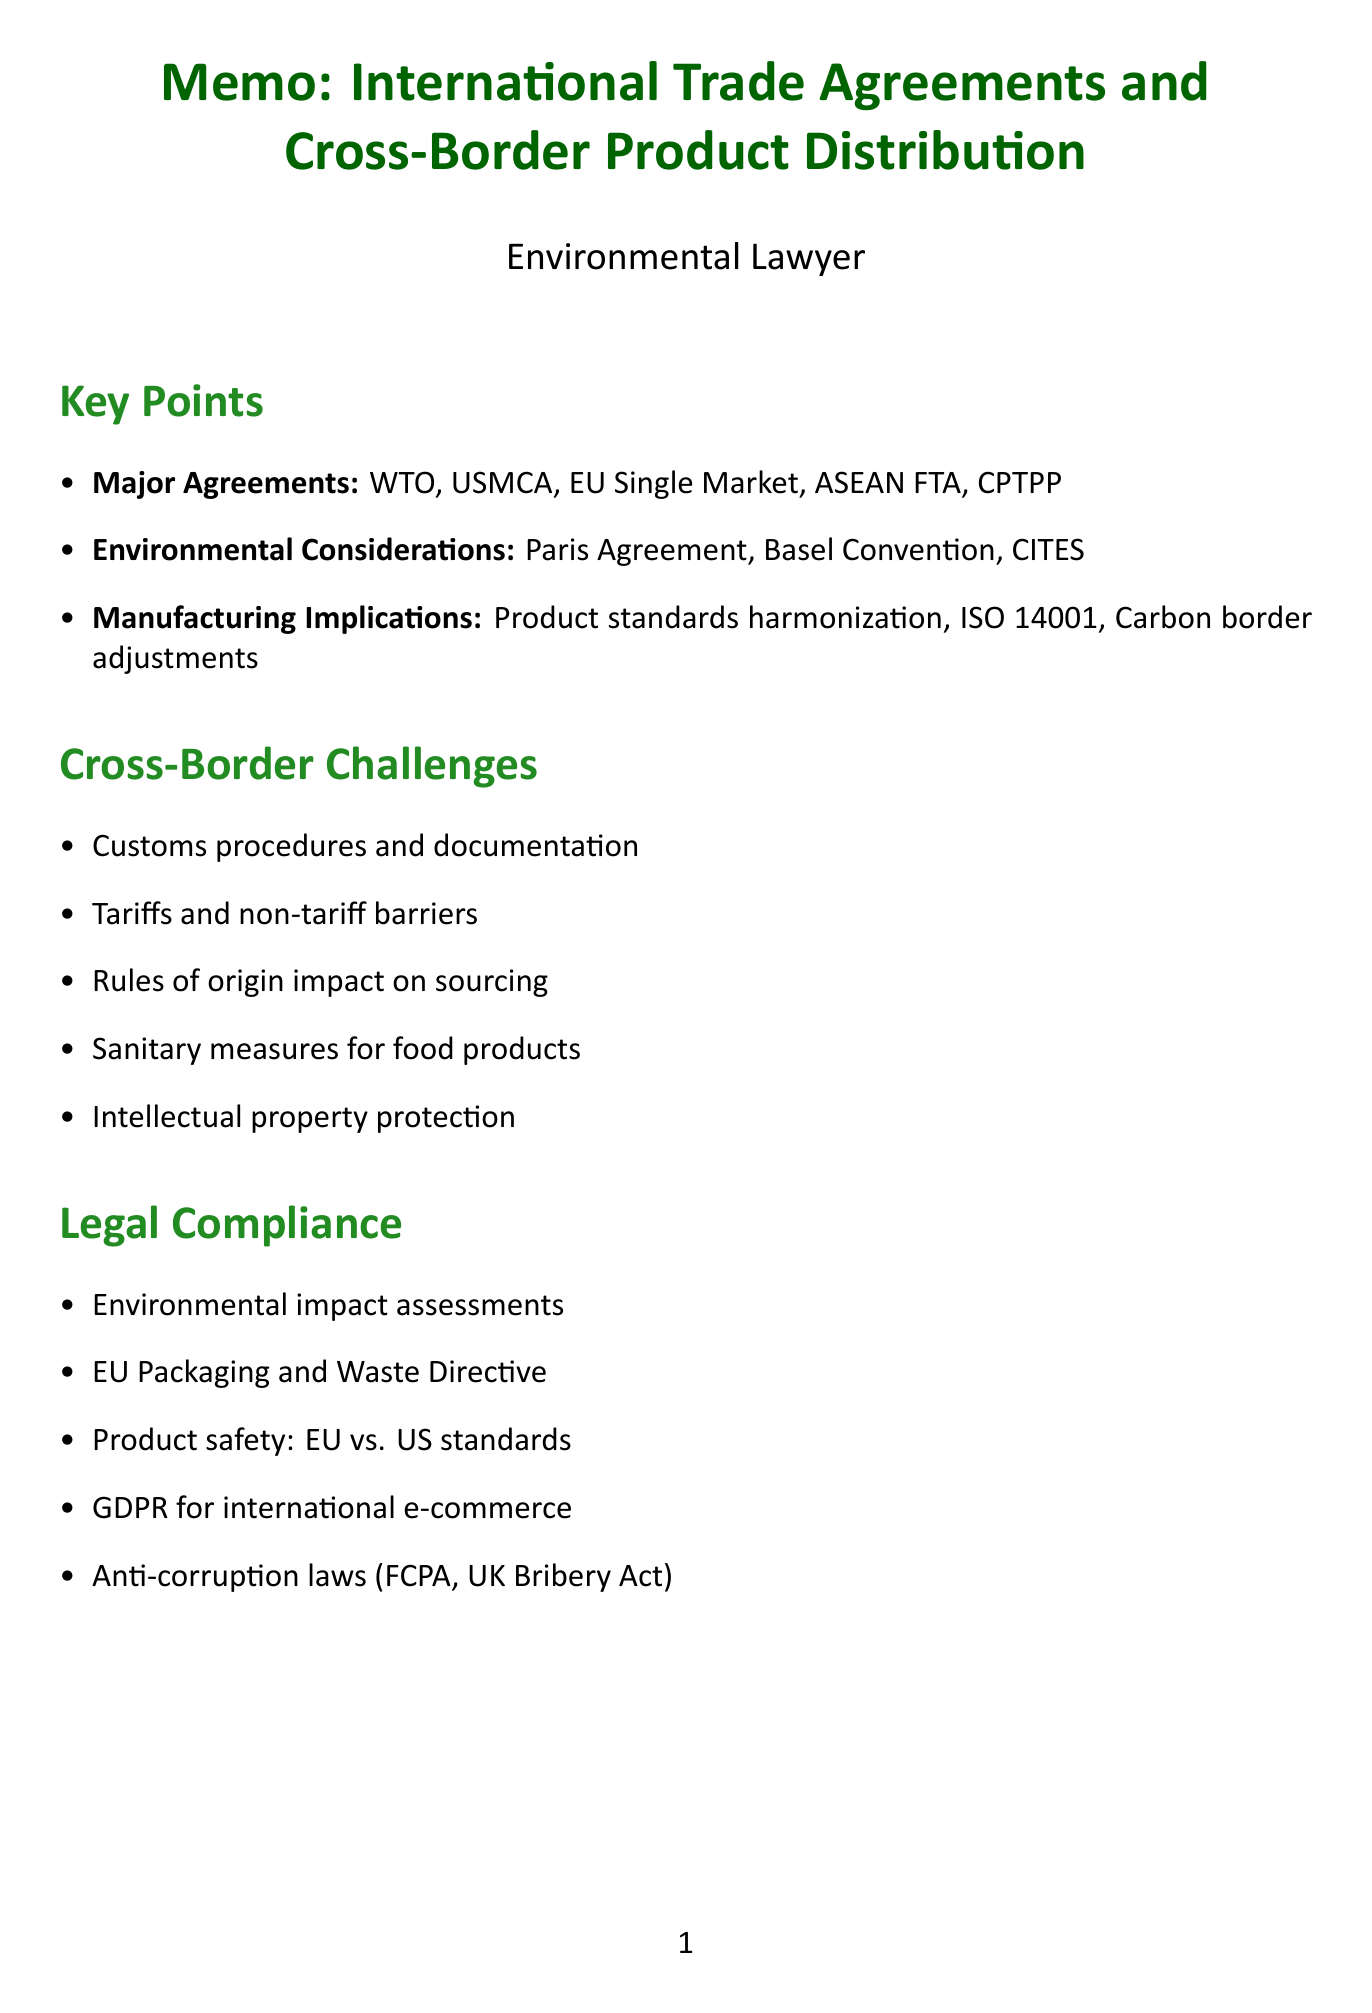What are the major trade agreements discussed? The document lists key international trade agreements including WTO, NAFTA/USMCA, EU Single Market, ASEAN FTA, and CPTPP.
Answer: WTO, NAFTA/USMCA, EU Single Market, ASEAN FTA, CPTPP What environmental agreement impacts international trade? The Paris Agreement is mentioned as having an impact on international trade.
Answer: Paris Agreement Which directive addresses packaging and waste in the EU? The EU's Packaging and Packaging Waste Directive is specified for packaging and labeling requirements.
Answer: EU's Packaging and Packaging Waste Directive What is one example of a company adapting to environmental regulations? The document mentions Nestlé's adaptation to plastic packaging regulations as a case study.
Answer: Nestlé What type of assessments are required for cross-border transportation? Environmental impact assessments are required as per the legal compliance section of the document.
Answer: Environmental impact assessments How does the document categorize compliance for product safety standards? It compares the General Product Safety Directive (EU) with the Consumer Product Safety Act (US).
Answer: General Product Safety Directive (EU) vs. Consumer Product Safety Act (US) What technology is noted for future supply chain transparency? The document highlights blockchain technology as a means for supply chain transparency.
Answer: Blockchain technology What are the duties arising from carbon border adjustments? Carbon border adjustment mechanisms impact manufacturing costs, as stated in the implications for manufacturing section.
Answer: Manufacturing costs What is the focus of the EU’s Circular Economy Action Plan? The focus is on the effect on product standards as mentioned under environmental considerations.
Answer: Product standards 